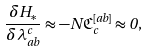<formula> <loc_0><loc_0><loc_500><loc_500>\frac { \delta { H } _ { * } } { \delta \lambda ^ { c } _ { a b } } \approx - N { \mathfrak C } ^ { [ a b ] } _ { c } \approx 0 ,</formula> 